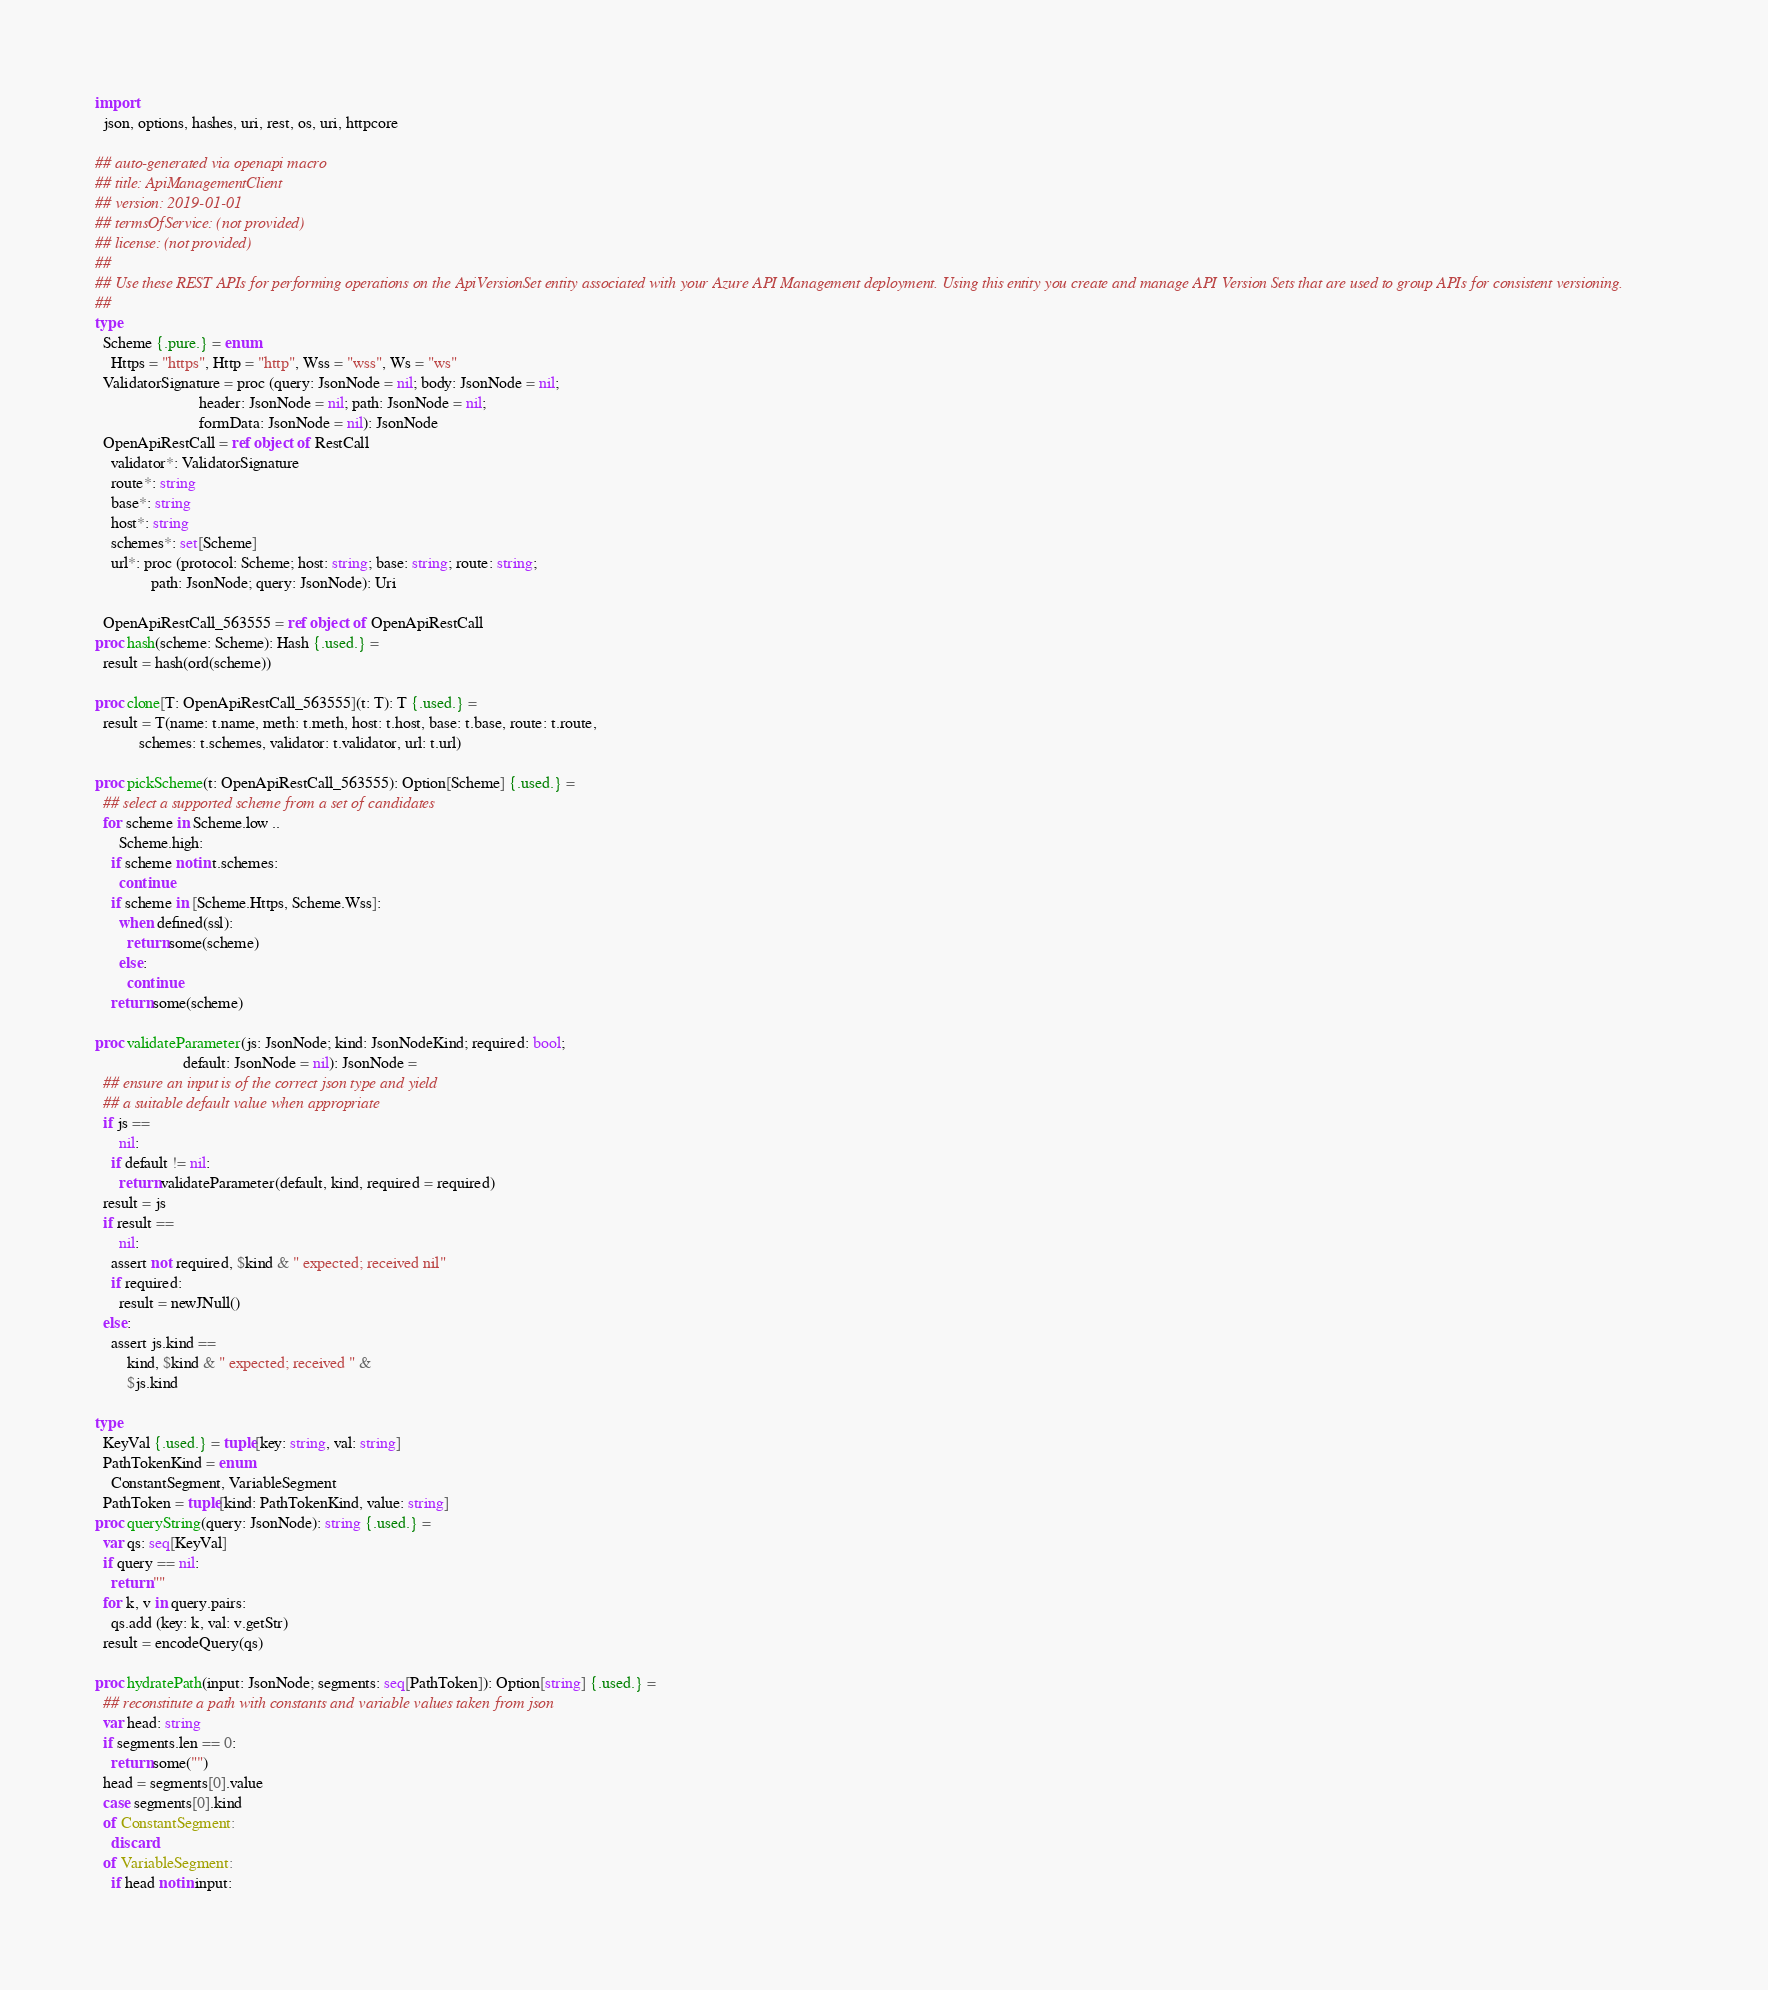<code> <loc_0><loc_0><loc_500><loc_500><_Nim_>
import
  json, options, hashes, uri, rest, os, uri, httpcore

## auto-generated via openapi macro
## title: ApiManagementClient
## version: 2019-01-01
## termsOfService: (not provided)
## license: (not provided)
## 
## Use these REST APIs for performing operations on the ApiVersionSet entity associated with your Azure API Management deployment. Using this entity you create and manage API Version Sets that are used to group APIs for consistent versioning.
## 
type
  Scheme {.pure.} = enum
    Https = "https", Http = "http", Wss = "wss", Ws = "ws"
  ValidatorSignature = proc (query: JsonNode = nil; body: JsonNode = nil;
                          header: JsonNode = nil; path: JsonNode = nil;
                          formData: JsonNode = nil): JsonNode
  OpenApiRestCall = ref object of RestCall
    validator*: ValidatorSignature
    route*: string
    base*: string
    host*: string
    schemes*: set[Scheme]
    url*: proc (protocol: Scheme; host: string; base: string; route: string;
              path: JsonNode; query: JsonNode): Uri

  OpenApiRestCall_563555 = ref object of OpenApiRestCall
proc hash(scheme: Scheme): Hash {.used.} =
  result = hash(ord(scheme))

proc clone[T: OpenApiRestCall_563555](t: T): T {.used.} =
  result = T(name: t.name, meth: t.meth, host: t.host, base: t.base, route: t.route,
           schemes: t.schemes, validator: t.validator, url: t.url)

proc pickScheme(t: OpenApiRestCall_563555): Option[Scheme] {.used.} =
  ## select a supported scheme from a set of candidates
  for scheme in Scheme.low ..
      Scheme.high:
    if scheme notin t.schemes:
      continue
    if scheme in [Scheme.Https, Scheme.Wss]:
      when defined(ssl):
        return some(scheme)
      else:
        continue
    return some(scheme)

proc validateParameter(js: JsonNode; kind: JsonNodeKind; required: bool;
                      default: JsonNode = nil): JsonNode =
  ## ensure an input is of the correct json type and yield
  ## a suitable default value when appropriate
  if js ==
      nil:
    if default != nil:
      return validateParameter(default, kind, required = required)
  result = js
  if result ==
      nil:
    assert not required, $kind & " expected; received nil"
    if required:
      result = newJNull()
  else:
    assert js.kind ==
        kind, $kind & " expected; received " &
        $js.kind

type
  KeyVal {.used.} = tuple[key: string, val: string]
  PathTokenKind = enum
    ConstantSegment, VariableSegment
  PathToken = tuple[kind: PathTokenKind, value: string]
proc queryString(query: JsonNode): string {.used.} =
  var qs: seq[KeyVal]
  if query == nil:
    return ""
  for k, v in query.pairs:
    qs.add (key: k, val: v.getStr)
  result = encodeQuery(qs)

proc hydratePath(input: JsonNode; segments: seq[PathToken]): Option[string] {.used.} =
  ## reconstitute a path with constants and variable values taken from json
  var head: string
  if segments.len == 0:
    return some("")
  head = segments[0].value
  case segments[0].kind
  of ConstantSegment:
    discard
  of VariableSegment:
    if head notin input:</code> 